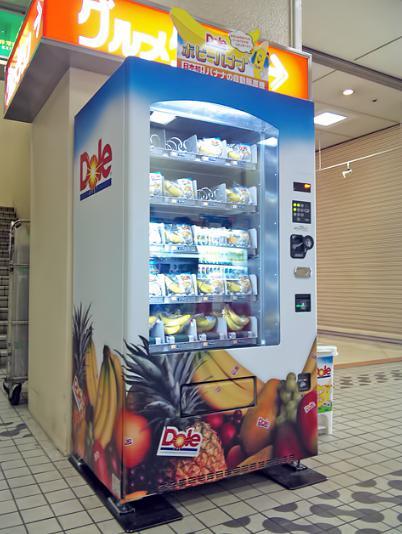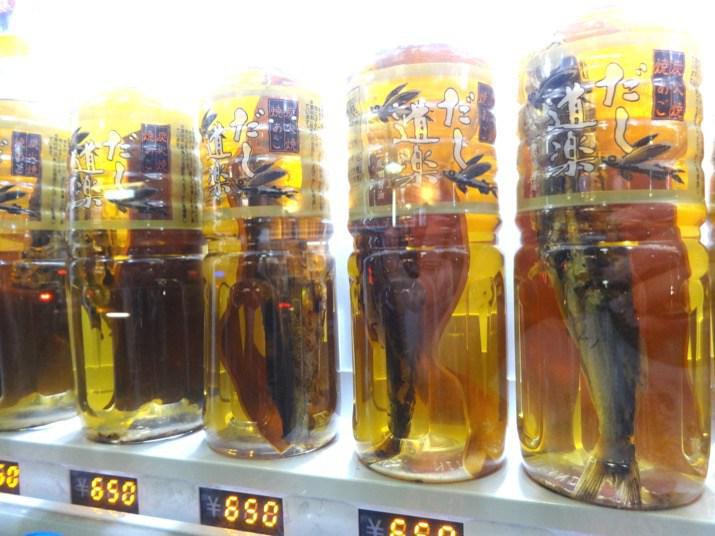The first image is the image on the left, the second image is the image on the right. Examine the images to the left and right. Is the description "Two trashcans are visible beside the vending machine in the image on the left." accurate? Answer yes or no. No. 